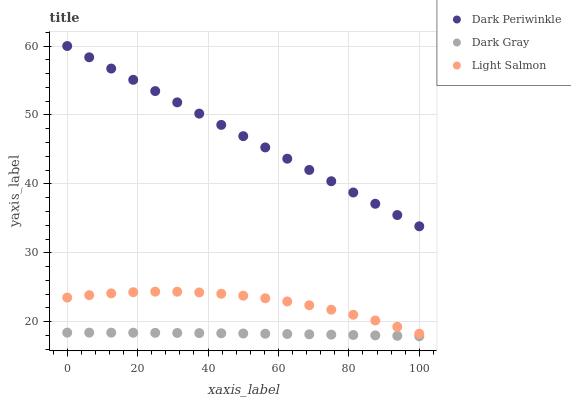Does Dark Gray have the minimum area under the curve?
Answer yes or no. Yes. Does Dark Periwinkle have the maximum area under the curve?
Answer yes or no. Yes. Does Light Salmon have the minimum area under the curve?
Answer yes or no. No. Does Light Salmon have the maximum area under the curve?
Answer yes or no. No. Is Dark Periwinkle the smoothest?
Answer yes or no. Yes. Is Light Salmon the roughest?
Answer yes or no. Yes. Is Light Salmon the smoothest?
Answer yes or no. No. Is Dark Periwinkle the roughest?
Answer yes or no. No. Does Dark Gray have the lowest value?
Answer yes or no. Yes. Does Light Salmon have the lowest value?
Answer yes or no. No. Does Dark Periwinkle have the highest value?
Answer yes or no. Yes. Does Light Salmon have the highest value?
Answer yes or no. No. Is Light Salmon less than Dark Periwinkle?
Answer yes or no. Yes. Is Light Salmon greater than Dark Gray?
Answer yes or no. Yes. Does Light Salmon intersect Dark Periwinkle?
Answer yes or no. No. 